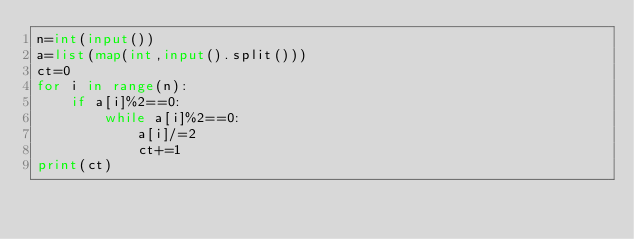Convert code to text. <code><loc_0><loc_0><loc_500><loc_500><_Python_>n=int(input())
a=list(map(int,input().split()))
ct=0
for i in range(n):
    if a[i]%2==0:
        while a[i]%2==0:
            a[i]/=2
            ct+=1
print(ct)</code> 